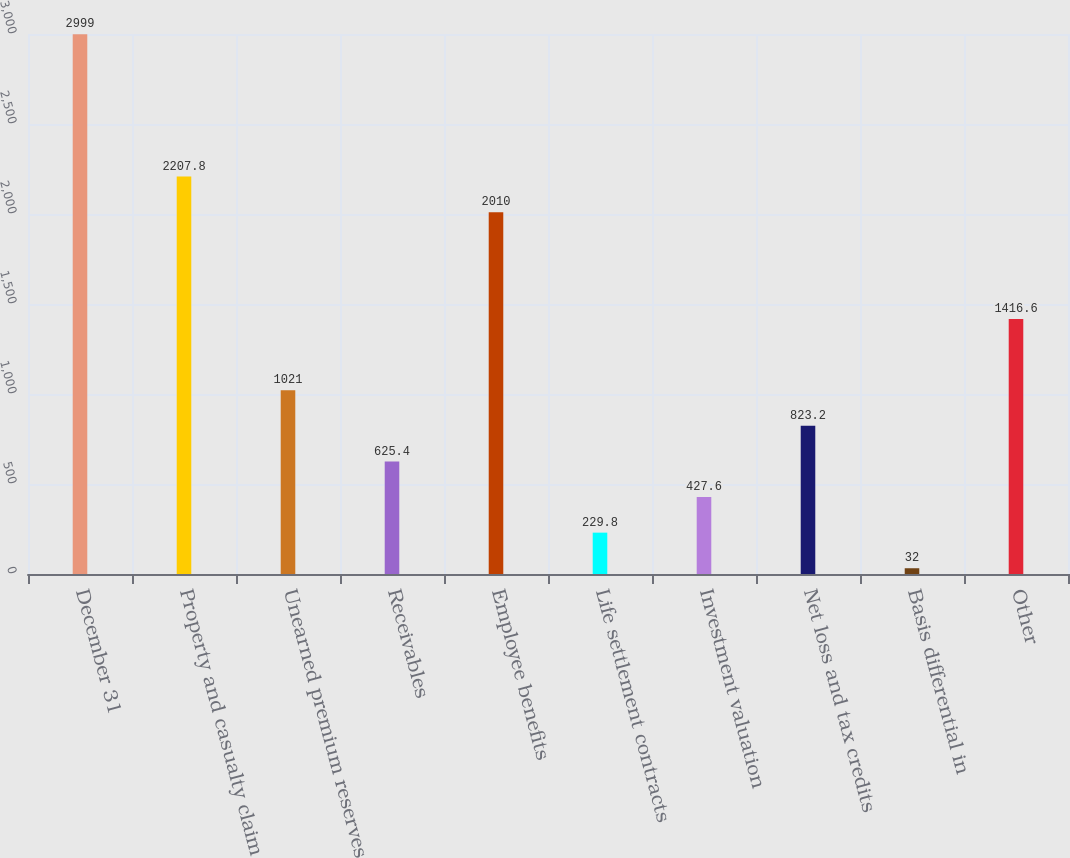<chart> <loc_0><loc_0><loc_500><loc_500><bar_chart><fcel>December 31<fcel>Property and casualty claim<fcel>Unearned premium reserves<fcel>Receivables<fcel>Employee benefits<fcel>Life settlement contracts<fcel>Investment valuation<fcel>Net loss and tax credits<fcel>Basis differential in<fcel>Other<nl><fcel>2999<fcel>2207.8<fcel>1021<fcel>625.4<fcel>2010<fcel>229.8<fcel>427.6<fcel>823.2<fcel>32<fcel>1416.6<nl></chart> 